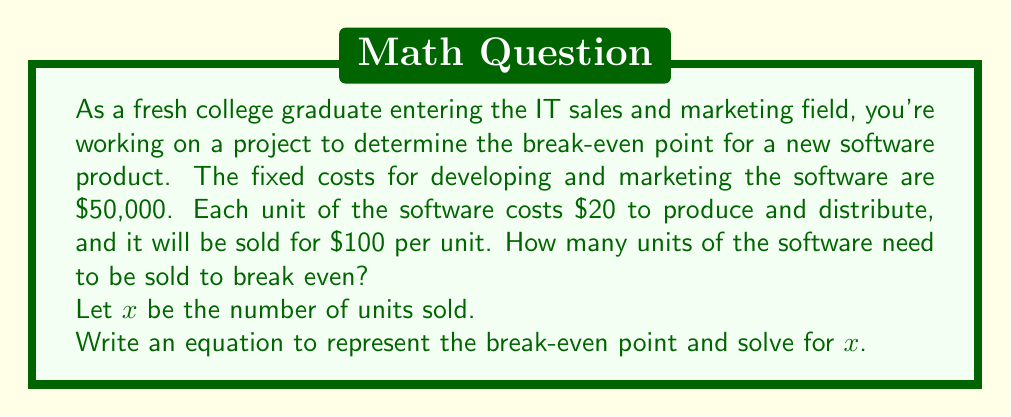Give your solution to this math problem. To solve this problem, we need to understand the concept of the break-even point. The break-even point is where total revenue equals total costs.

Let's define our variables:
$x$ = number of units sold
Fixed costs = $50,000
Variable cost per unit = $20
Selling price per unit = $100

Now, let's set up our equation:

Total Revenue = Total Costs

$$ 100x = 50000 + 20x $$

This equation states that the revenue from selling $x$ units at $100 each should equal the fixed costs plus the variable costs for producing $x$ units.

To solve for $x$:

1) Subtract $20x$ from both sides:
   $$ 80x = 50000 $$

2) Divide both sides by 80:
   $$ x = \frac{50000}{80} = 625 $$

Therefore, the company needs to sell 625 units to break even.

To verify:
Revenue: $100 * 625 = $62,500
Costs: $50,000 + ($20 * 625) = $62,500

Revenue equals costs, confirming the break-even point.
Answer: The break-even point is 625 units. 